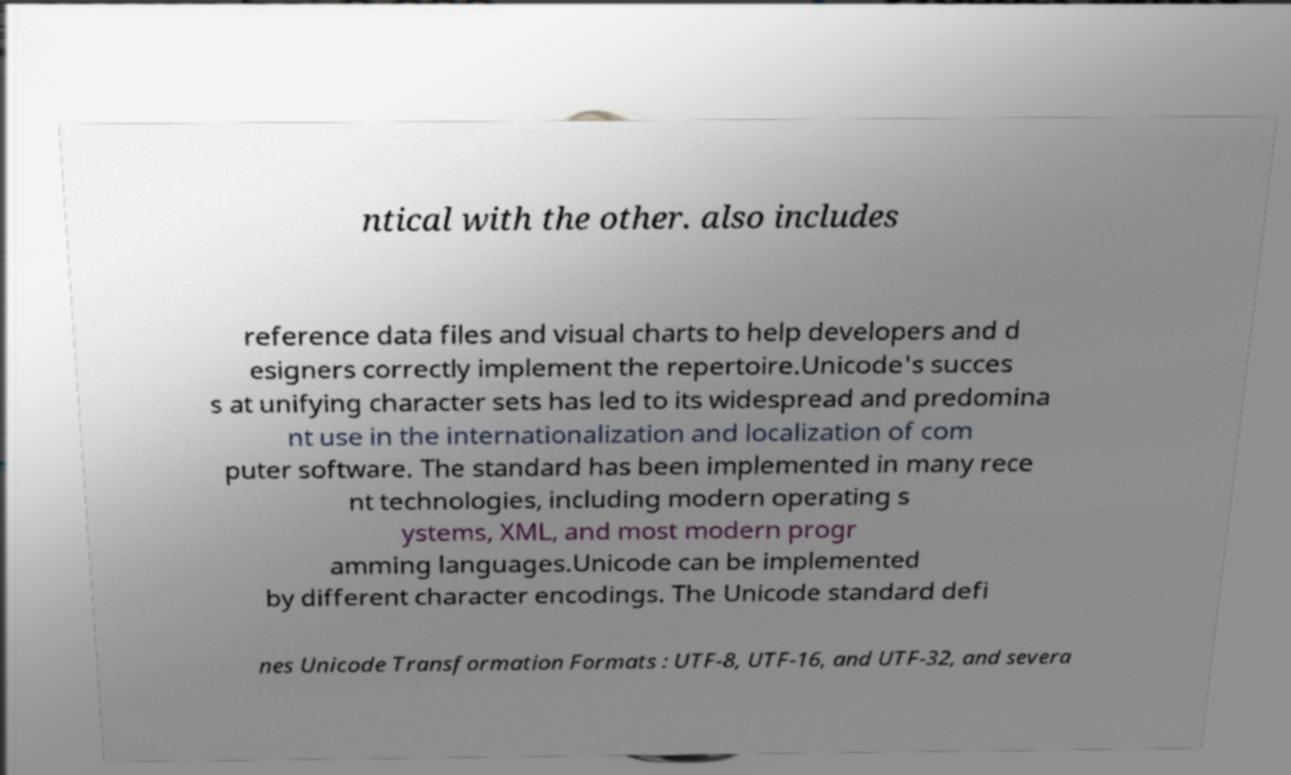For documentation purposes, I need the text within this image transcribed. Could you provide that? ntical with the other. also includes reference data files and visual charts to help developers and d esigners correctly implement the repertoire.Unicode's succes s at unifying character sets has led to its widespread and predomina nt use in the internationalization and localization of com puter software. The standard has been implemented in many rece nt technologies, including modern operating s ystems, XML, and most modern progr amming languages.Unicode can be implemented by different character encodings. The Unicode standard defi nes Unicode Transformation Formats : UTF-8, UTF-16, and UTF-32, and severa 